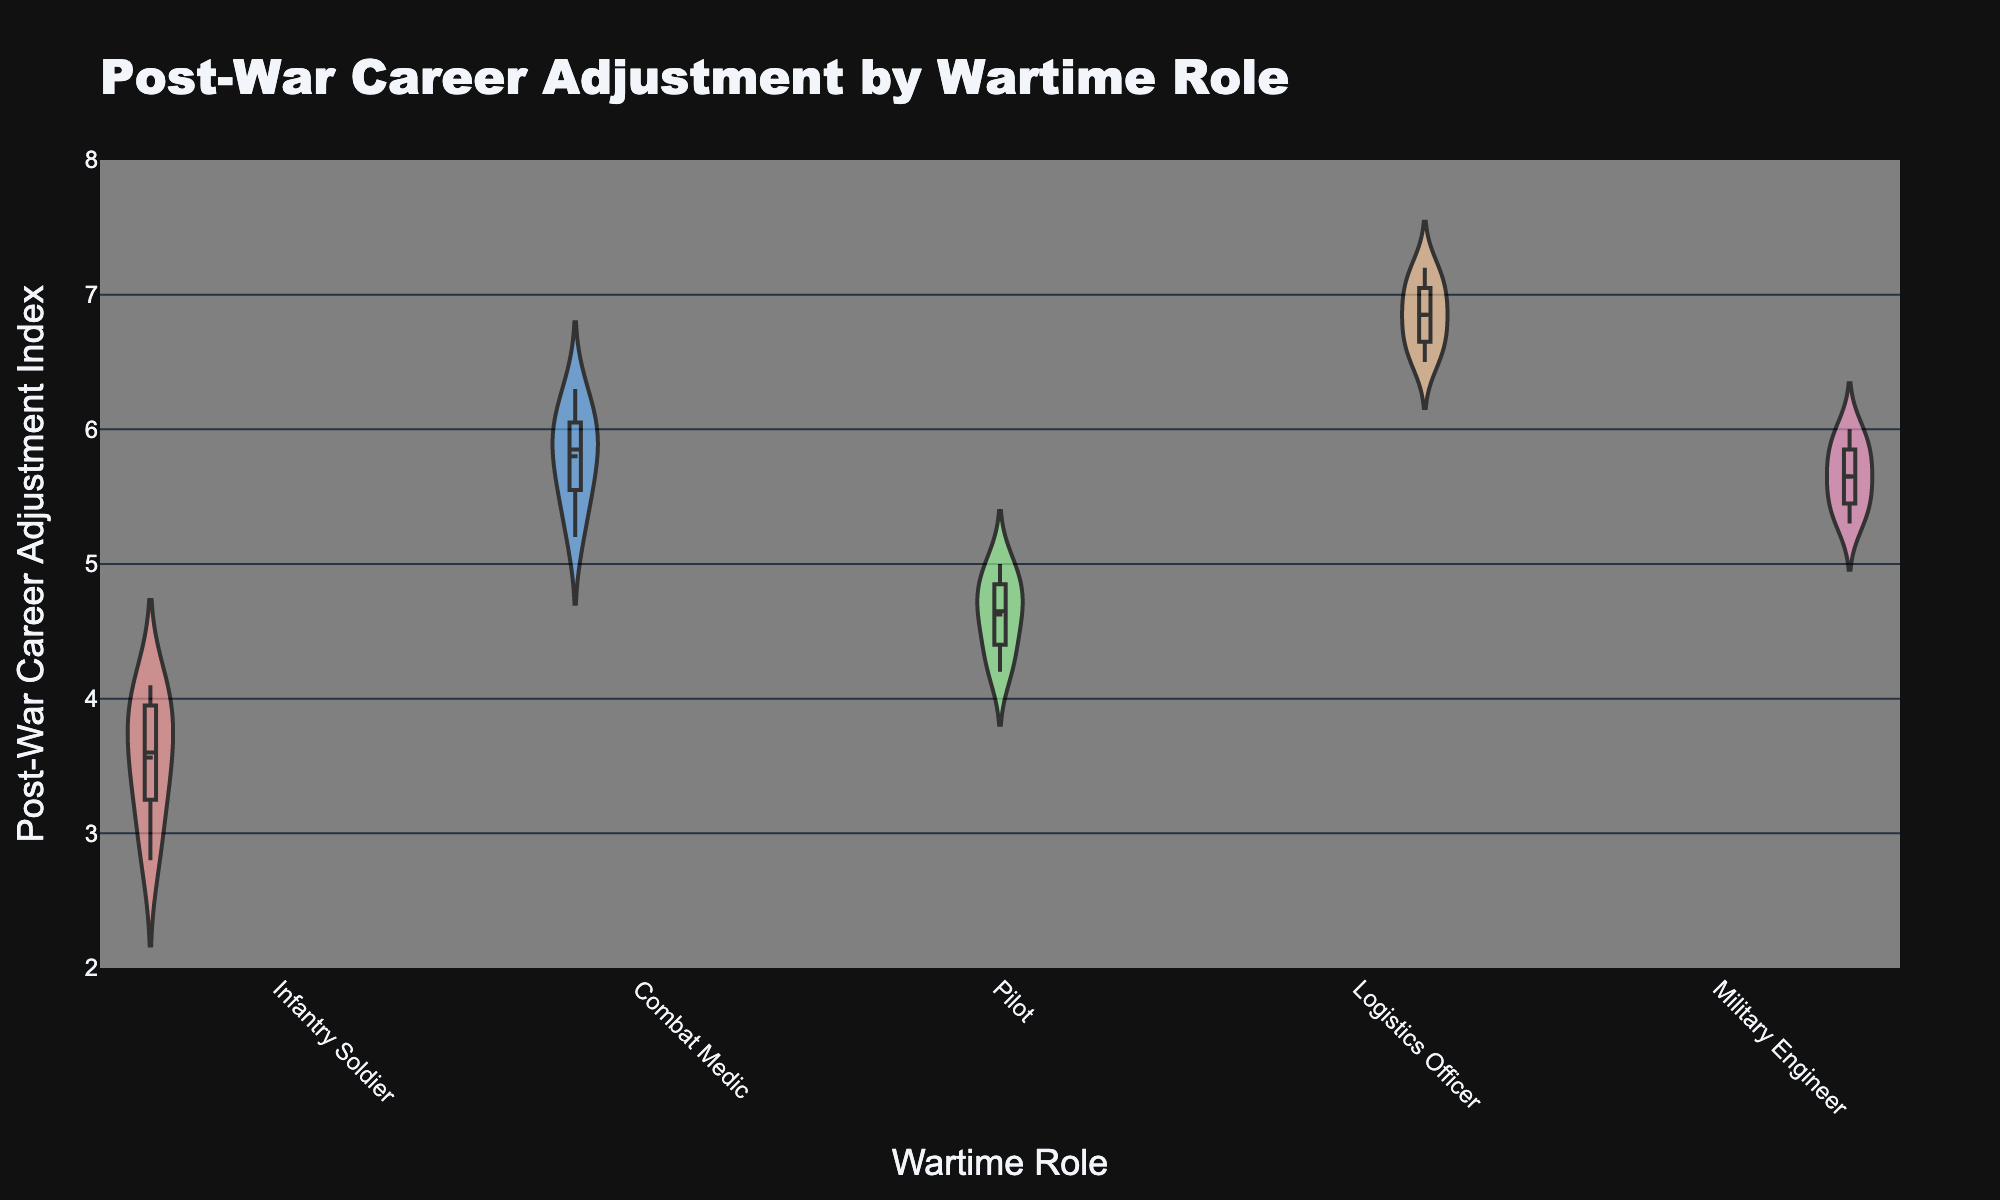What is the title of the figure? The title of the figure can be found at the top of the plot. It reads "Post-War Career Adjustment by Wartime Role".
Answer: Post-War Career Adjustment by Wartime Role What does the x-axis represent in the figure? The x-axis represents the categories of Wartime Roles which include Infantry Soldier, Combat Medic, Pilot, Logistics Officer, and Military Engineer.
Answer: Wartime Role What is the range of the y-axis in the figure? The range of the y-axis can be determined by looking at the minimum and maximum values indicated along the y-axis. It ranges from 2 to 8.
Answer: 2 to 8 Which wartime role appears to have the highest median Post-War Career Adjustment Index? Each violin plot includes a box plot, and the median is indicated by the line within the box. The wartime role with the highest median line is Logistics Officer.
Answer: Logistics Officer How many different wartime roles are compared in the figure? The number of wartime roles can be counted by identifying the different categories on the x-axis. There are five distinct wartime roles.
Answer: 5 Which wartime role shows the most variability in post-war career adjustments? Variability is indicated by the width and spread of the violin plot. The widest and most spread-out plot belongs to Combat Medic.
Answer: Combat Medic Is the mean Post-War Career Adjustment Index higher for Pilots or Infantry Soldiers? The mean is shown by a dashed line within each violin plot. Comparing the position of these lines, the mean for Pilots is higher than that for Infantry Soldiers.
Answer: Pilots What can be said about the overlap between the Post-War Career Adjustment Indexes of Combat Medics and Military Engineers? By visually comparing the violin plots for both roles, one can observe that there is a significant overlap around the 5.5 to 6 range.
Answer: Significant overlap Which wartime role has the narrowest interquartile range (IQR) for Post-War Career Adjustment Index? The IQR is the range between the first quartile (bottom of the box) and third quartile (top of the box) of the box plot. By examining the box plots, Pilots have the narrowest IQR.
Answer: Pilots How do the Post-War Career Adjustment Indexes for Logistics Officers compare to those of Infantry Soldiers? By comparing the two plots, Logistics Officers have generally higher values and a higher median, while Infantry Soldiers have lower values overall.
Answer: Logistics Officers have higher values 